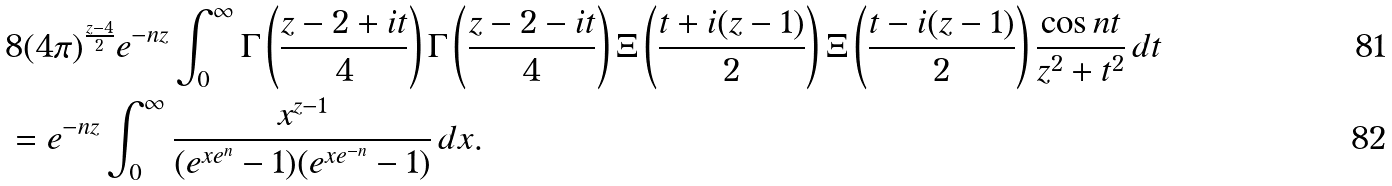Convert formula to latex. <formula><loc_0><loc_0><loc_500><loc_500>& 8 ( 4 \pi ) ^ { \frac { z - 4 } { 2 } } e ^ { - n z } \int _ { 0 } ^ { \infty } \Gamma \left ( \frac { z - 2 + i t } { 4 } \right ) \Gamma \left ( \frac { z - 2 - i t } { 4 } \right ) \Xi \left ( \frac { t + i ( z - 1 ) } { 2 } \right ) \Xi \left ( \frac { t - i ( z - 1 ) } { 2 } \right ) \frac { \cos n t } { z ^ { 2 } + t ^ { 2 } } \, d t \\ & = e ^ { - n z } \int _ { 0 } ^ { \infty } \frac { x ^ { z - 1 } } { ( e ^ { x e ^ { n } } - 1 ) ( e ^ { x e ^ { - n } } - 1 ) } \, d x .</formula> 